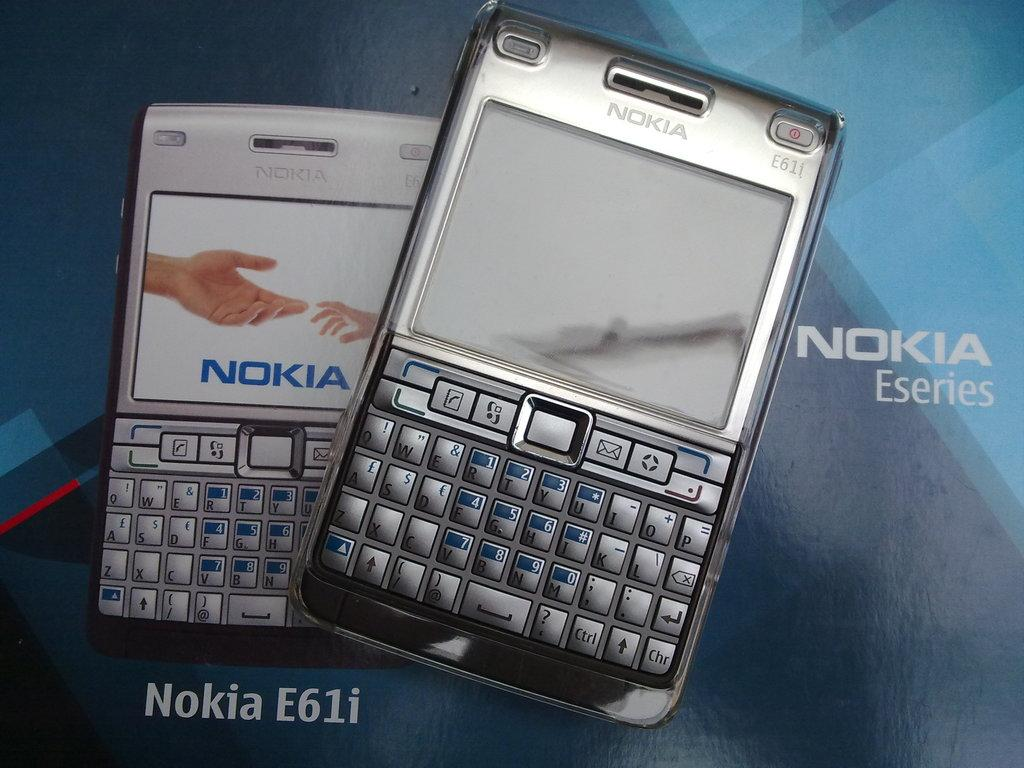<image>
Offer a succinct explanation of the picture presented. Advertisement for Nokia E61i featuring two phones with a blue background. 